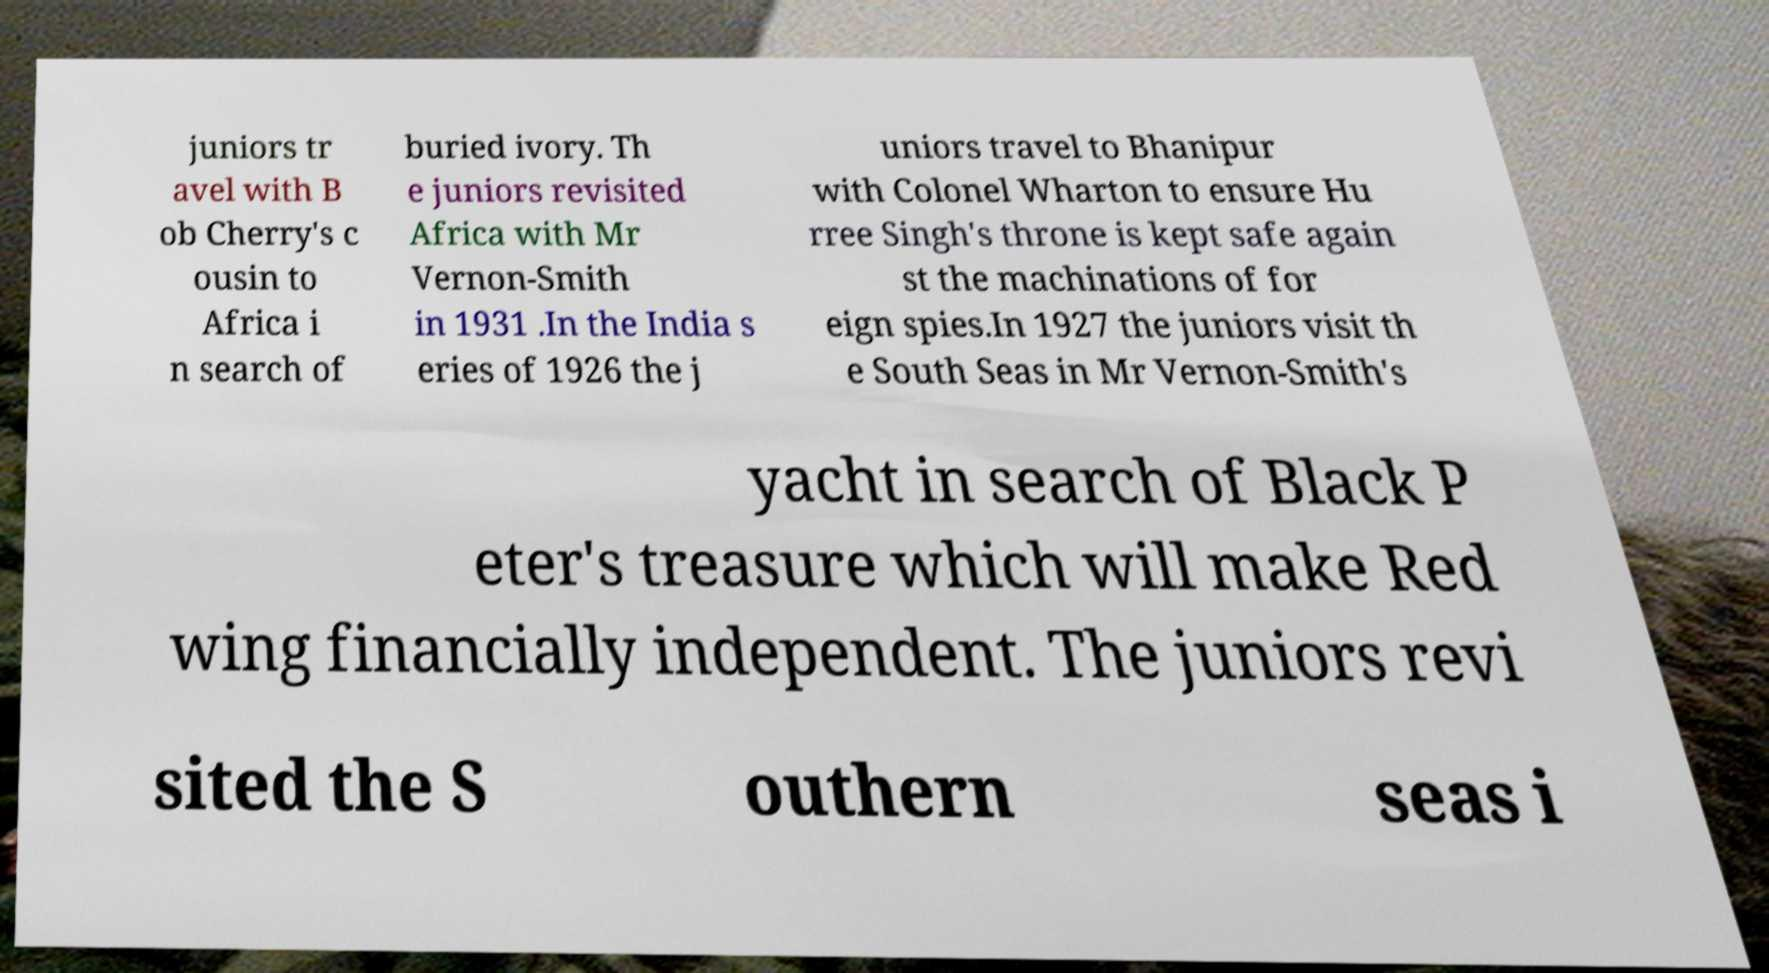I need the written content from this picture converted into text. Can you do that? juniors tr avel with B ob Cherry's c ousin to Africa i n search of buried ivory. Th e juniors revisited Africa with Mr Vernon-Smith in 1931 .In the India s eries of 1926 the j uniors travel to Bhanipur with Colonel Wharton to ensure Hu rree Singh's throne is kept safe again st the machinations of for eign spies.In 1927 the juniors visit th e South Seas in Mr Vernon-Smith's yacht in search of Black P eter's treasure which will make Red wing financially independent. The juniors revi sited the S outhern seas i 